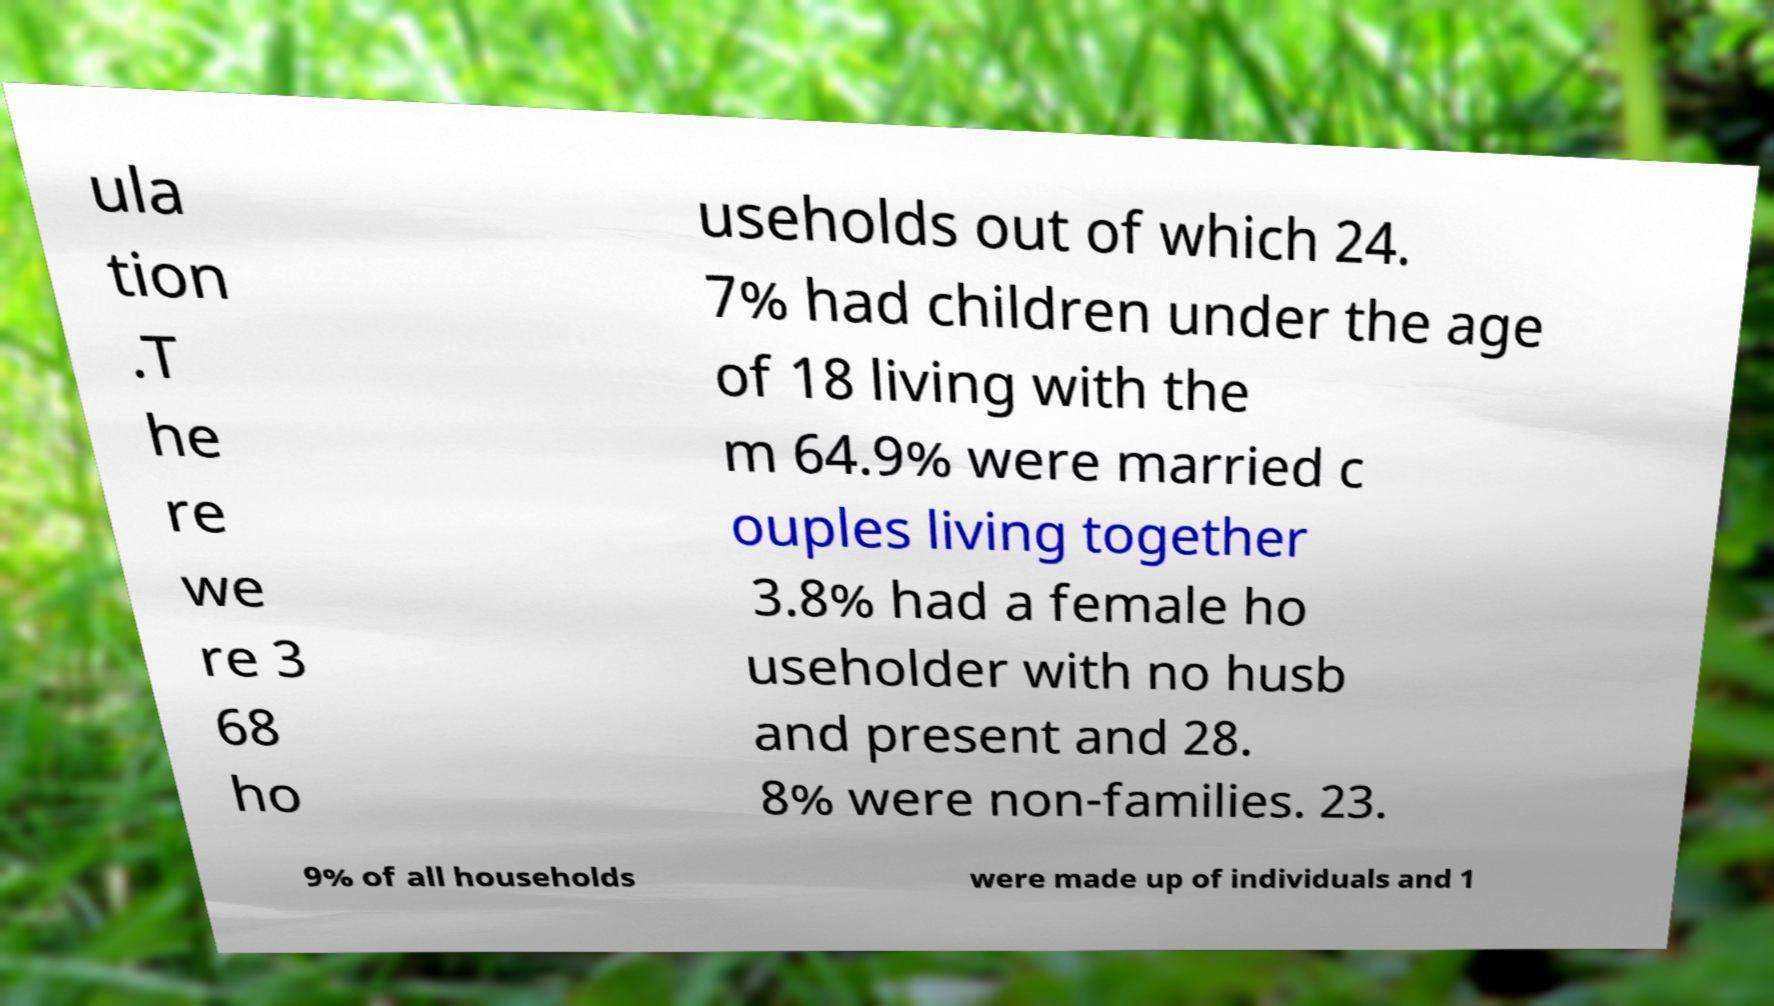Can you accurately transcribe the text from the provided image for me? ula tion .T he re we re 3 68 ho useholds out of which 24. 7% had children under the age of 18 living with the m 64.9% were married c ouples living together 3.8% had a female ho useholder with no husb and present and 28. 8% were non-families. 23. 9% of all households were made up of individuals and 1 